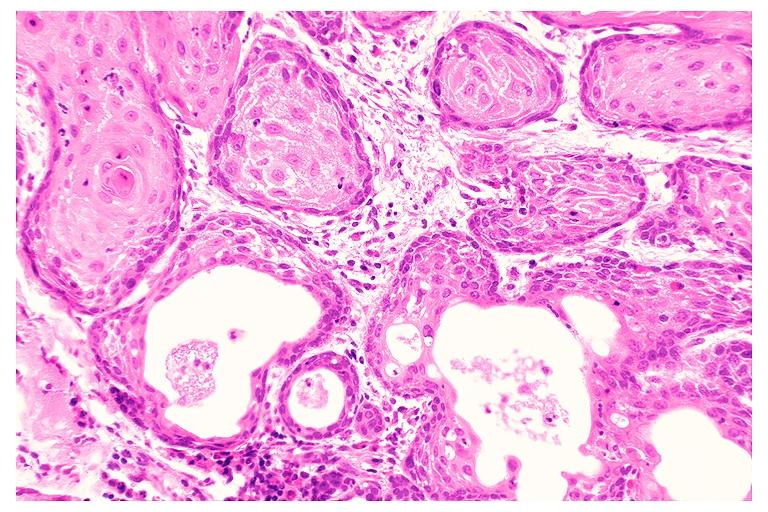does intraductal papillomatosis show necrotizing sialometaplasia?
Answer the question using a single word or phrase. No 